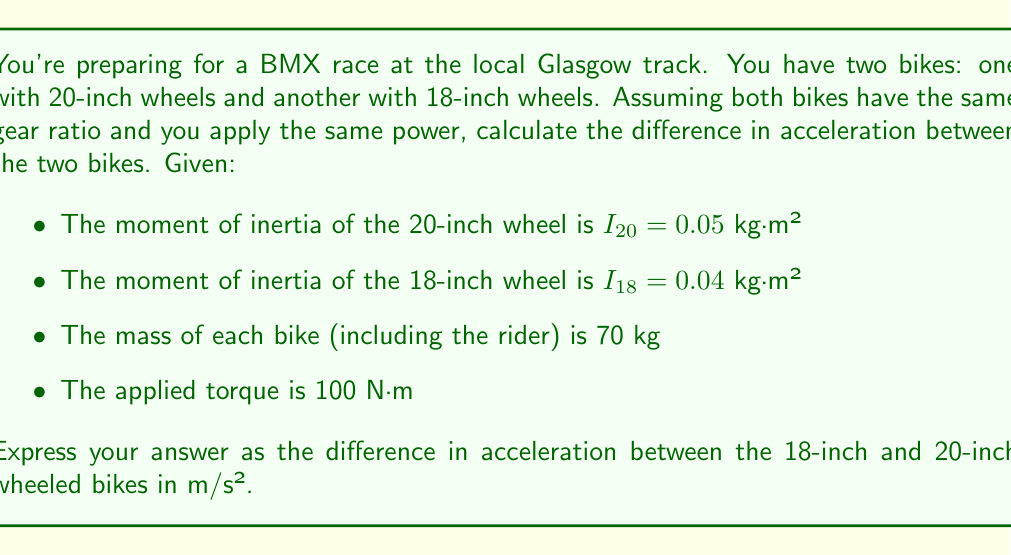Provide a solution to this math problem. To solve this problem, we need to use the relationship between torque, moment of inertia, and angular acceleration, and then convert angular acceleration to linear acceleration. Let's break it down step-by-step:

1) The relationship between torque ($\tau$), moment of inertia ($I$), and angular acceleration ($\alpha$) is:

   $$\tau = I\alpha$$

2) Rearranging this equation, we can find the angular acceleration:

   $$\alpha = \frac{\tau}{I}$$

3) For the 20-inch wheel:
   $$\alpha_{20} = \frac{100}{0.05} = 2000 \text{ rad/s²}$$

4) For the 18-inch wheel:
   $$\alpha_{18} = \frac{100}{0.04} = 2500 \text{ rad/s²}$$

5) To convert angular acceleration to linear acceleration, we use the formula:

   $$a = \alpha r$$

   where $r$ is the radius of the wheel.

6) The radius of a 20-inch wheel is 10 inches or 0.254 m, and for an 18-inch wheel, it's 9 inches or 0.2286 m.

7) Linear acceleration for the 20-inch wheel:
   $$a_{20} = 2000 \times 0.254 = 508 \text{ m/s²}$$

8) Linear acceleration for the 18-inch wheel:
   $$a_{18} = 2500 \times 0.2286 = 571.5 \text{ m/s²}$$

9) The difference in acceleration is:
   $$\Delta a = a_{18} - a_{20} = 571.5 - 508 = 63.5 \text{ m/s²}$$

Therefore, the 18-inch wheeled bike accelerates 63.5 m/s² faster than the 20-inch wheeled bike under the given conditions.
Answer: 63.5 m/s² 